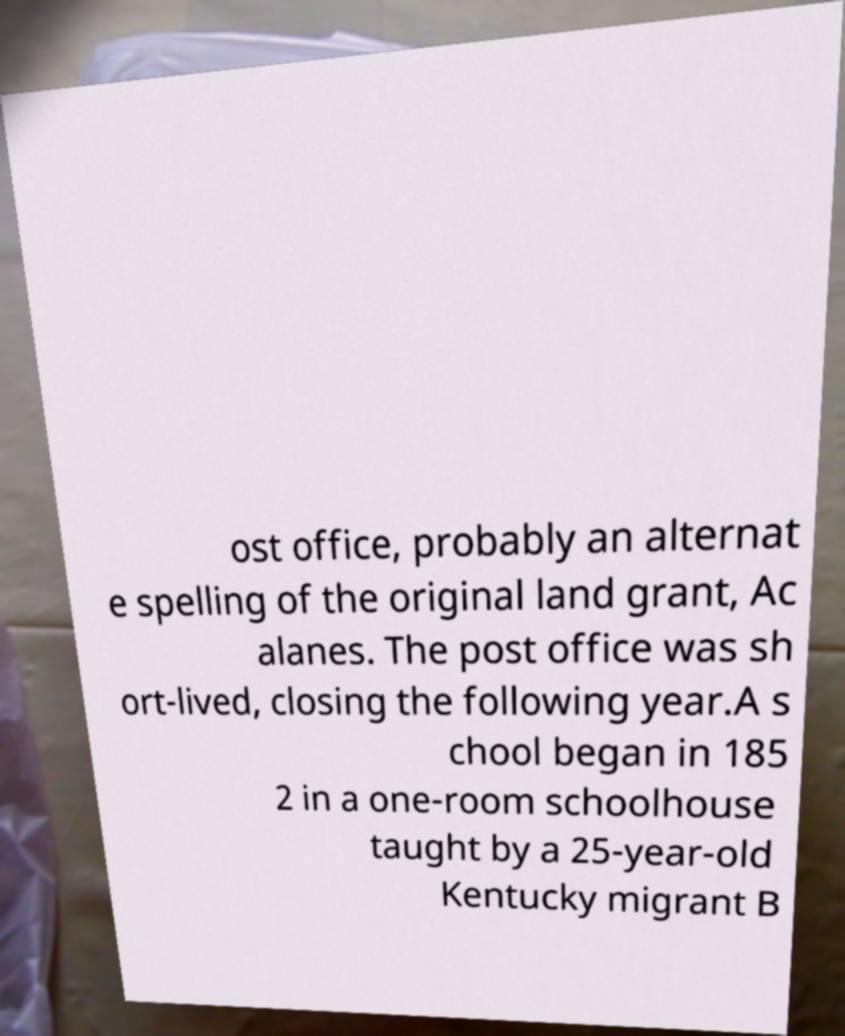For documentation purposes, I need the text within this image transcribed. Could you provide that? ost office, probably an alternat e spelling of the original land grant, Ac alanes. The post office was sh ort-lived, closing the following year.A s chool began in 185 2 in a one-room schoolhouse taught by a 25-year-old Kentucky migrant B 